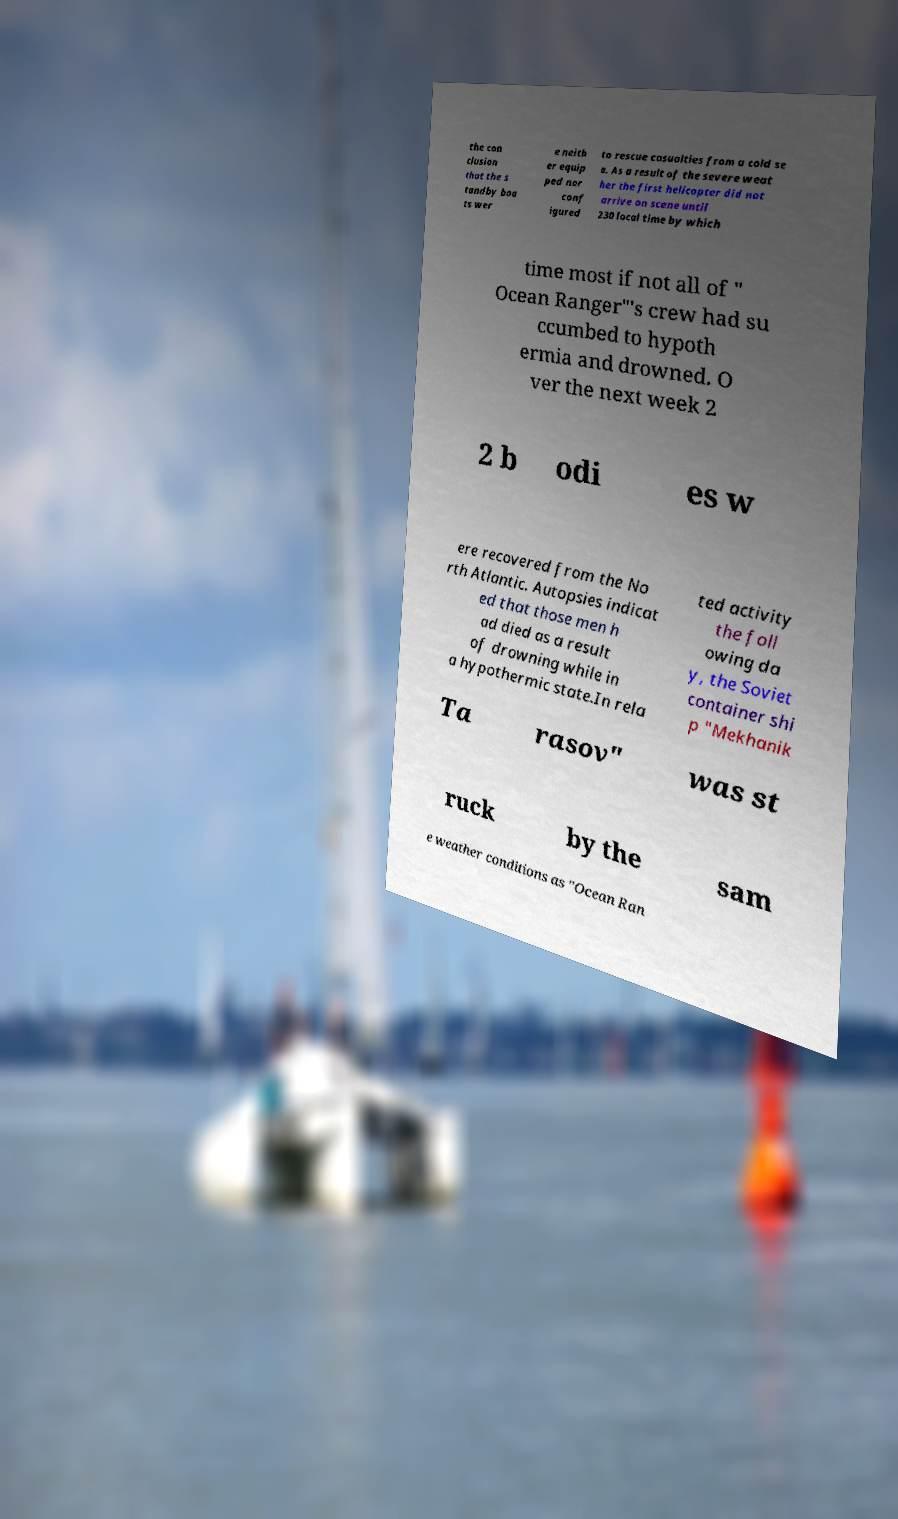Please identify and transcribe the text found in this image. the con clusion that the s tandby boa ts wer e neith er equip ped nor conf igured to rescue casualties from a cold se a. As a result of the severe weat her the first helicopter did not arrive on scene until 230 local time by which time most if not all of " Ocean Ranger"'s crew had su ccumbed to hypoth ermia and drowned. O ver the next week 2 2 b odi es w ere recovered from the No rth Atlantic. Autopsies indicat ed that those men h ad died as a result of drowning while in a hypothermic state.In rela ted activity the foll owing da y, the Soviet container shi p "Mekhanik Ta rasov" was st ruck by the sam e weather conditions as "Ocean Ran 